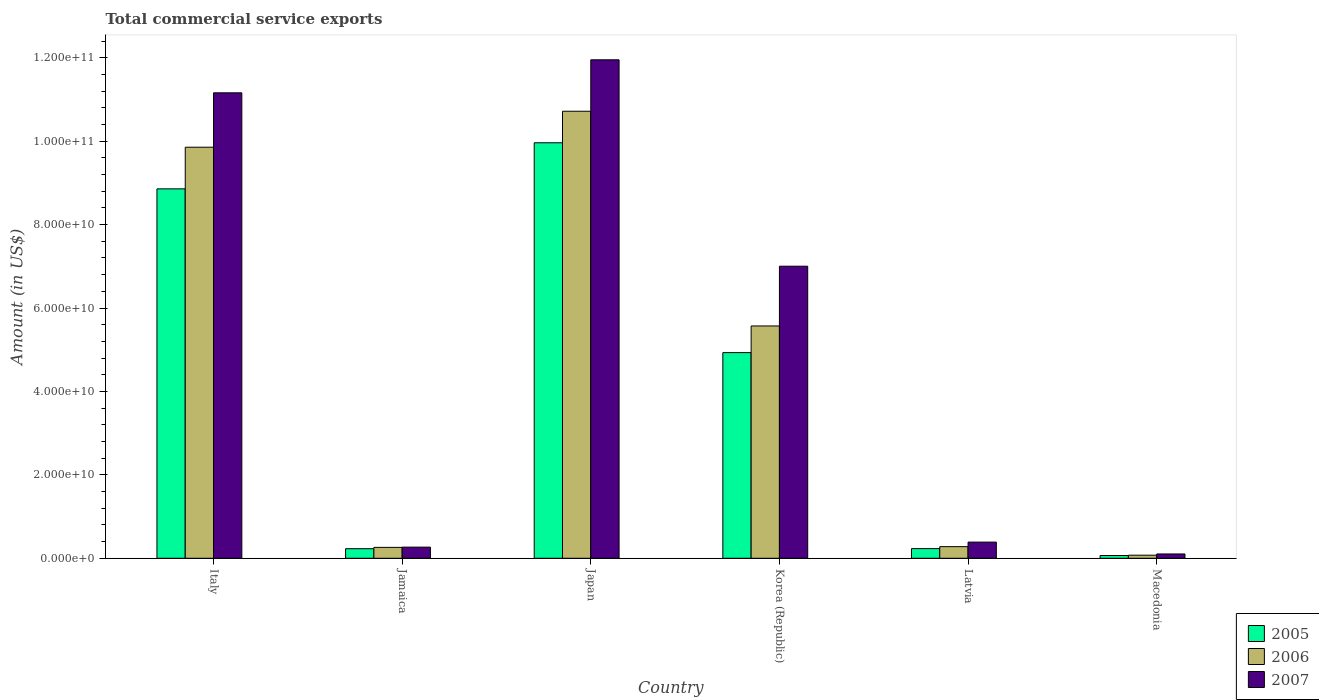How many groups of bars are there?
Your answer should be compact. 6. Are the number of bars on each tick of the X-axis equal?
Keep it short and to the point. Yes. What is the label of the 1st group of bars from the left?
Your answer should be compact. Italy. In how many cases, is the number of bars for a given country not equal to the number of legend labels?
Offer a terse response. 0. What is the total commercial service exports in 2006 in Italy?
Your answer should be very brief. 9.86e+1. Across all countries, what is the maximum total commercial service exports in 2007?
Your answer should be very brief. 1.20e+11. Across all countries, what is the minimum total commercial service exports in 2005?
Provide a short and direct response. 6.60e+08. In which country was the total commercial service exports in 2007 maximum?
Provide a succinct answer. Japan. In which country was the total commercial service exports in 2005 minimum?
Your answer should be compact. Macedonia. What is the total total commercial service exports in 2005 in the graph?
Offer a very short reply. 2.43e+11. What is the difference between the total commercial service exports in 2006 in Italy and that in Latvia?
Provide a succinct answer. 9.58e+1. What is the difference between the total commercial service exports in 2005 in Latvia and the total commercial service exports in 2007 in Japan?
Make the answer very short. -1.17e+11. What is the average total commercial service exports in 2006 per country?
Offer a very short reply. 4.46e+1. What is the difference between the total commercial service exports of/in 2005 and total commercial service exports of/in 2006 in Jamaica?
Keep it short and to the point. -3.18e+08. In how many countries, is the total commercial service exports in 2006 greater than 64000000000 US$?
Offer a terse response. 2. What is the ratio of the total commercial service exports in 2007 in Japan to that in Macedonia?
Make the answer very short. 115.58. Is the total commercial service exports in 2005 in Italy less than that in Japan?
Keep it short and to the point. Yes. Is the difference between the total commercial service exports in 2005 in Jamaica and Japan greater than the difference between the total commercial service exports in 2006 in Jamaica and Japan?
Your answer should be very brief. Yes. What is the difference between the highest and the second highest total commercial service exports in 2006?
Offer a very short reply. -4.29e+1. What is the difference between the highest and the lowest total commercial service exports in 2005?
Your answer should be compact. 9.90e+1. In how many countries, is the total commercial service exports in 2006 greater than the average total commercial service exports in 2006 taken over all countries?
Offer a very short reply. 3. Is it the case that in every country, the sum of the total commercial service exports in 2005 and total commercial service exports in 2006 is greater than the total commercial service exports in 2007?
Your answer should be compact. Yes. How many bars are there?
Your response must be concise. 18. What is the difference between two consecutive major ticks on the Y-axis?
Your response must be concise. 2.00e+1. Are the values on the major ticks of Y-axis written in scientific E-notation?
Your response must be concise. Yes. Does the graph contain grids?
Your answer should be very brief. No. How are the legend labels stacked?
Provide a succinct answer. Vertical. What is the title of the graph?
Keep it short and to the point. Total commercial service exports. What is the label or title of the X-axis?
Offer a terse response. Country. What is the label or title of the Y-axis?
Your answer should be very brief. Amount (in US$). What is the Amount (in US$) in 2005 in Italy?
Your answer should be compact. 8.86e+1. What is the Amount (in US$) in 2006 in Italy?
Your response must be concise. 9.86e+1. What is the Amount (in US$) in 2007 in Italy?
Your response must be concise. 1.12e+11. What is the Amount (in US$) in 2005 in Jamaica?
Offer a terse response. 2.30e+09. What is the Amount (in US$) of 2006 in Jamaica?
Your answer should be very brief. 2.61e+09. What is the Amount (in US$) of 2007 in Jamaica?
Give a very brief answer. 2.67e+09. What is the Amount (in US$) in 2005 in Japan?
Your answer should be compact. 9.96e+1. What is the Amount (in US$) of 2006 in Japan?
Offer a terse response. 1.07e+11. What is the Amount (in US$) in 2007 in Japan?
Your answer should be compact. 1.20e+11. What is the Amount (in US$) in 2005 in Korea (Republic)?
Give a very brief answer. 4.93e+1. What is the Amount (in US$) in 2006 in Korea (Republic)?
Keep it short and to the point. 5.57e+1. What is the Amount (in US$) in 2007 in Korea (Republic)?
Your answer should be compact. 7.00e+1. What is the Amount (in US$) in 2005 in Latvia?
Offer a terse response. 2.32e+09. What is the Amount (in US$) in 2006 in Latvia?
Make the answer very short. 2.79e+09. What is the Amount (in US$) in 2007 in Latvia?
Ensure brevity in your answer.  3.88e+09. What is the Amount (in US$) of 2005 in Macedonia?
Provide a short and direct response. 6.60e+08. What is the Amount (in US$) in 2006 in Macedonia?
Provide a short and direct response. 7.38e+08. What is the Amount (in US$) of 2007 in Macedonia?
Give a very brief answer. 1.03e+09. Across all countries, what is the maximum Amount (in US$) in 2005?
Provide a short and direct response. 9.96e+1. Across all countries, what is the maximum Amount (in US$) of 2006?
Your answer should be very brief. 1.07e+11. Across all countries, what is the maximum Amount (in US$) of 2007?
Provide a short and direct response. 1.20e+11. Across all countries, what is the minimum Amount (in US$) in 2005?
Your response must be concise. 6.60e+08. Across all countries, what is the minimum Amount (in US$) of 2006?
Give a very brief answer. 7.38e+08. Across all countries, what is the minimum Amount (in US$) of 2007?
Provide a succinct answer. 1.03e+09. What is the total Amount (in US$) in 2005 in the graph?
Your response must be concise. 2.43e+11. What is the total Amount (in US$) in 2006 in the graph?
Your answer should be compact. 2.68e+11. What is the total Amount (in US$) in 2007 in the graph?
Your response must be concise. 3.09e+11. What is the difference between the Amount (in US$) in 2005 in Italy and that in Jamaica?
Make the answer very short. 8.63e+1. What is the difference between the Amount (in US$) in 2006 in Italy and that in Jamaica?
Offer a terse response. 9.59e+1. What is the difference between the Amount (in US$) of 2007 in Italy and that in Jamaica?
Keep it short and to the point. 1.09e+11. What is the difference between the Amount (in US$) of 2005 in Italy and that in Japan?
Offer a very short reply. -1.10e+1. What is the difference between the Amount (in US$) of 2006 in Italy and that in Japan?
Provide a short and direct response. -8.63e+09. What is the difference between the Amount (in US$) of 2007 in Italy and that in Japan?
Your answer should be compact. -7.92e+09. What is the difference between the Amount (in US$) of 2005 in Italy and that in Korea (Republic)?
Your response must be concise. 3.93e+1. What is the difference between the Amount (in US$) of 2006 in Italy and that in Korea (Republic)?
Give a very brief answer. 4.29e+1. What is the difference between the Amount (in US$) of 2007 in Italy and that in Korea (Republic)?
Ensure brevity in your answer.  4.16e+1. What is the difference between the Amount (in US$) in 2005 in Italy and that in Latvia?
Ensure brevity in your answer.  8.63e+1. What is the difference between the Amount (in US$) in 2006 in Italy and that in Latvia?
Keep it short and to the point. 9.58e+1. What is the difference between the Amount (in US$) of 2007 in Italy and that in Latvia?
Offer a terse response. 1.08e+11. What is the difference between the Amount (in US$) in 2005 in Italy and that in Macedonia?
Your answer should be compact. 8.79e+1. What is the difference between the Amount (in US$) of 2006 in Italy and that in Macedonia?
Ensure brevity in your answer.  9.78e+1. What is the difference between the Amount (in US$) of 2007 in Italy and that in Macedonia?
Provide a succinct answer. 1.11e+11. What is the difference between the Amount (in US$) in 2005 in Jamaica and that in Japan?
Keep it short and to the point. -9.73e+1. What is the difference between the Amount (in US$) in 2006 in Jamaica and that in Japan?
Keep it short and to the point. -1.05e+11. What is the difference between the Amount (in US$) in 2007 in Jamaica and that in Japan?
Your response must be concise. -1.17e+11. What is the difference between the Amount (in US$) in 2005 in Jamaica and that in Korea (Republic)?
Your response must be concise. -4.70e+1. What is the difference between the Amount (in US$) of 2006 in Jamaica and that in Korea (Republic)?
Provide a short and direct response. -5.31e+1. What is the difference between the Amount (in US$) of 2007 in Jamaica and that in Korea (Republic)?
Offer a terse response. -6.74e+1. What is the difference between the Amount (in US$) of 2005 in Jamaica and that in Latvia?
Make the answer very short. -2.24e+07. What is the difference between the Amount (in US$) in 2006 in Jamaica and that in Latvia?
Your answer should be compact. -1.75e+08. What is the difference between the Amount (in US$) of 2007 in Jamaica and that in Latvia?
Keep it short and to the point. -1.21e+09. What is the difference between the Amount (in US$) of 2005 in Jamaica and that in Macedonia?
Your answer should be compact. 1.64e+09. What is the difference between the Amount (in US$) in 2006 in Jamaica and that in Macedonia?
Offer a terse response. 1.88e+09. What is the difference between the Amount (in US$) of 2007 in Jamaica and that in Macedonia?
Your response must be concise. 1.64e+09. What is the difference between the Amount (in US$) in 2005 in Japan and that in Korea (Republic)?
Make the answer very short. 5.03e+1. What is the difference between the Amount (in US$) in 2006 in Japan and that in Korea (Republic)?
Keep it short and to the point. 5.15e+1. What is the difference between the Amount (in US$) in 2007 in Japan and that in Korea (Republic)?
Your response must be concise. 4.95e+1. What is the difference between the Amount (in US$) in 2005 in Japan and that in Latvia?
Your response must be concise. 9.73e+1. What is the difference between the Amount (in US$) of 2006 in Japan and that in Latvia?
Keep it short and to the point. 1.04e+11. What is the difference between the Amount (in US$) in 2007 in Japan and that in Latvia?
Give a very brief answer. 1.16e+11. What is the difference between the Amount (in US$) in 2005 in Japan and that in Macedonia?
Give a very brief answer. 9.90e+1. What is the difference between the Amount (in US$) of 2006 in Japan and that in Macedonia?
Your answer should be compact. 1.06e+11. What is the difference between the Amount (in US$) in 2007 in Japan and that in Macedonia?
Your answer should be very brief. 1.18e+11. What is the difference between the Amount (in US$) of 2005 in Korea (Republic) and that in Latvia?
Make the answer very short. 4.70e+1. What is the difference between the Amount (in US$) of 2006 in Korea (Republic) and that in Latvia?
Keep it short and to the point. 5.29e+1. What is the difference between the Amount (in US$) in 2007 in Korea (Republic) and that in Latvia?
Provide a short and direct response. 6.62e+1. What is the difference between the Amount (in US$) in 2005 in Korea (Republic) and that in Macedonia?
Offer a terse response. 4.87e+1. What is the difference between the Amount (in US$) in 2006 in Korea (Republic) and that in Macedonia?
Keep it short and to the point. 5.50e+1. What is the difference between the Amount (in US$) of 2007 in Korea (Republic) and that in Macedonia?
Keep it short and to the point. 6.90e+1. What is the difference between the Amount (in US$) in 2005 in Latvia and that in Macedonia?
Your response must be concise. 1.66e+09. What is the difference between the Amount (in US$) of 2006 in Latvia and that in Macedonia?
Offer a terse response. 2.05e+09. What is the difference between the Amount (in US$) in 2007 in Latvia and that in Macedonia?
Give a very brief answer. 2.84e+09. What is the difference between the Amount (in US$) in 2005 in Italy and the Amount (in US$) in 2006 in Jamaica?
Keep it short and to the point. 8.60e+1. What is the difference between the Amount (in US$) in 2005 in Italy and the Amount (in US$) in 2007 in Jamaica?
Your answer should be very brief. 8.59e+1. What is the difference between the Amount (in US$) in 2006 in Italy and the Amount (in US$) in 2007 in Jamaica?
Your answer should be compact. 9.59e+1. What is the difference between the Amount (in US$) in 2005 in Italy and the Amount (in US$) in 2006 in Japan?
Offer a terse response. -1.86e+1. What is the difference between the Amount (in US$) in 2005 in Italy and the Amount (in US$) in 2007 in Japan?
Keep it short and to the point. -3.09e+1. What is the difference between the Amount (in US$) in 2006 in Italy and the Amount (in US$) in 2007 in Japan?
Your answer should be very brief. -2.10e+1. What is the difference between the Amount (in US$) in 2005 in Italy and the Amount (in US$) in 2006 in Korea (Republic)?
Offer a very short reply. 3.29e+1. What is the difference between the Amount (in US$) in 2005 in Italy and the Amount (in US$) in 2007 in Korea (Republic)?
Your response must be concise. 1.85e+1. What is the difference between the Amount (in US$) of 2006 in Italy and the Amount (in US$) of 2007 in Korea (Republic)?
Provide a succinct answer. 2.85e+1. What is the difference between the Amount (in US$) in 2005 in Italy and the Amount (in US$) in 2006 in Latvia?
Offer a very short reply. 8.58e+1. What is the difference between the Amount (in US$) in 2005 in Italy and the Amount (in US$) in 2007 in Latvia?
Offer a terse response. 8.47e+1. What is the difference between the Amount (in US$) in 2006 in Italy and the Amount (in US$) in 2007 in Latvia?
Offer a terse response. 9.47e+1. What is the difference between the Amount (in US$) of 2005 in Italy and the Amount (in US$) of 2006 in Macedonia?
Provide a succinct answer. 8.78e+1. What is the difference between the Amount (in US$) in 2005 in Italy and the Amount (in US$) in 2007 in Macedonia?
Make the answer very short. 8.75e+1. What is the difference between the Amount (in US$) in 2006 in Italy and the Amount (in US$) in 2007 in Macedonia?
Ensure brevity in your answer.  9.75e+1. What is the difference between the Amount (in US$) of 2005 in Jamaica and the Amount (in US$) of 2006 in Japan?
Offer a very short reply. -1.05e+11. What is the difference between the Amount (in US$) in 2005 in Jamaica and the Amount (in US$) in 2007 in Japan?
Give a very brief answer. -1.17e+11. What is the difference between the Amount (in US$) of 2006 in Jamaica and the Amount (in US$) of 2007 in Japan?
Make the answer very short. -1.17e+11. What is the difference between the Amount (in US$) in 2005 in Jamaica and the Amount (in US$) in 2006 in Korea (Republic)?
Offer a terse response. -5.34e+1. What is the difference between the Amount (in US$) in 2005 in Jamaica and the Amount (in US$) in 2007 in Korea (Republic)?
Ensure brevity in your answer.  -6.77e+1. What is the difference between the Amount (in US$) of 2006 in Jamaica and the Amount (in US$) of 2007 in Korea (Republic)?
Your answer should be very brief. -6.74e+1. What is the difference between the Amount (in US$) of 2005 in Jamaica and the Amount (in US$) of 2006 in Latvia?
Ensure brevity in your answer.  -4.93e+08. What is the difference between the Amount (in US$) of 2005 in Jamaica and the Amount (in US$) of 2007 in Latvia?
Offer a very short reply. -1.58e+09. What is the difference between the Amount (in US$) in 2006 in Jamaica and the Amount (in US$) in 2007 in Latvia?
Your answer should be compact. -1.26e+09. What is the difference between the Amount (in US$) of 2005 in Jamaica and the Amount (in US$) of 2006 in Macedonia?
Your response must be concise. 1.56e+09. What is the difference between the Amount (in US$) in 2005 in Jamaica and the Amount (in US$) in 2007 in Macedonia?
Provide a succinct answer. 1.26e+09. What is the difference between the Amount (in US$) in 2006 in Jamaica and the Amount (in US$) in 2007 in Macedonia?
Provide a succinct answer. 1.58e+09. What is the difference between the Amount (in US$) of 2005 in Japan and the Amount (in US$) of 2006 in Korea (Republic)?
Your answer should be very brief. 4.39e+1. What is the difference between the Amount (in US$) of 2005 in Japan and the Amount (in US$) of 2007 in Korea (Republic)?
Make the answer very short. 2.96e+1. What is the difference between the Amount (in US$) of 2006 in Japan and the Amount (in US$) of 2007 in Korea (Republic)?
Your response must be concise. 3.72e+1. What is the difference between the Amount (in US$) of 2005 in Japan and the Amount (in US$) of 2006 in Latvia?
Provide a short and direct response. 9.68e+1. What is the difference between the Amount (in US$) of 2005 in Japan and the Amount (in US$) of 2007 in Latvia?
Ensure brevity in your answer.  9.57e+1. What is the difference between the Amount (in US$) of 2006 in Japan and the Amount (in US$) of 2007 in Latvia?
Ensure brevity in your answer.  1.03e+11. What is the difference between the Amount (in US$) of 2005 in Japan and the Amount (in US$) of 2006 in Macedonia?
Your response must be concise. 9.89e+1. What is the difference between the Amount (in US$) in 2005 in Japan and the Amount (in US$) in 2007 in Macedonia?
Keep it short and to the point. 9.86e+1. What is the difference between the Amount (in US$) of 2006 in Japan and the Amount (in US$) of 2007 in Macedonia?
Your answer should be very brief. 1.06e+11. What is the difference between the Amount (in US$) of 2005 in Korea (Republic) and the Amount (in US$) of 2006 in Latvia?
Your response must be concise. 4.65e+1. What is the difference between the Amount (in US$) in 2005 in Korea (Republic) and the Amount (in US$) in 2007 in Latvia?
Your response must be concise. 4.54e+1. What is the difference between the Amount (in US$) in 2006 in Korea (Republic) and the Amount (in US$) in 2007 in Latvia?
Offer a terse response. 5.18e+1. What is the difference between the Amount (in US$) in 2005 in Korea (Republic) and the Amount (in US$) in 2006 in Macedonia?
Offer a terse response. 4.86e+1. What is the difference between the Amount (in US$) in 2005 in Korea (Republic) and the Amount (in US$) in 2007 in Macedonia?
Give a very brief answer. 4.83e+1. What is the difference between the Amount (in US$) in 2006 in Korea (Republic) and the Amount (in US$) in 2007 in Macedonia?
Your answer should be very brief. 5.47e+1. What is the difference between the Amount (in US$) in 2005 in Latvia and the Amount (in US$) in 2006 in Macedonia?
Your response must be concise. 1.58e+09. What is the difference between the Amount (in US$) in 2005 in Latvia and the Amount (in US$) in 2007 in Macedonia?
Make the answer very short. 1.28e+09. What is the difference between the Amount (in US$) of 2006 in Latvia and the Amount (in US$) of 2007 in Macedonia?
Offer a terse response. 1.75e+09. What is the average Amount (in US$) of 2005 per country?
Your response must be concise. 4.05e+1. What is the average Amount (in US$) of 2006 per country?
Ensure brevity in your answer.  4.46e+1. What is the average Amount (in US$) of 2007 per country?
Provide a short and direct response. 5.15e+1. What is the difference between the Amount (in US$) in 2005 and Amount (in US$) in 2006 in Italy?
Make the answer very short. -9.98e+09. What is the difference between the Amount (in US$) in 2005 and Amount (in US$) in 2007 in Italy?
Ensure brevity in your answer.  -2.30e+1. What is the difference between the Amount (in US$) of 2006 and Amount (in US$) of 2007 in Italy?
Offer a very short reply. -1.30e+1. What is the difference between the Amount (in US$) in 2005 and Amount (in US$) in 2006 in Jamaica?
Offer a terse response. -3.18e+08. What is the difference between the Amount (in US$) of 2005 and Amount (in US$) of 2007 in Jamaica?
Ensure brevity in your answer.  -3.74e+08. What is the difference between the Amount (in US$) in 2006 and Amount (in US$) in 2007 in Jamaica?
Keep it short and to the point. -5.61e+07. What is the difference between the Amount (in US$) of 2005 and Amount (in US$) of 2006 in Japan?
Provide a succinct answer. -7.56e+09. What is the difference between the Amount (in US$) in 2005 and Amount (in US$) in 2007 in Japan?
Keep it short and to the point. -1.99e+1. What is the difference between the Amount (in US$) of 2006 and Amount (in US$) of 2007 in Japan?
Provide a short and direct response. -1.23e+1. What is the difference between the Amount (in US$) in 2005 and Amount (in US$) in 2006 in Korea (Republic)?
Your answer should be very brief. -6.39e+09. What is the difference between the Amount (in US$) in 2005 and Amount (in US$) in 2007 in Korea (Republic)?
Your answer should be very brief. -2.07e+1. What is the difference between the Amount (in US$) of 2006 and Amount (in US$) of 2007 in Korea (Republic)?
Your answer should be very brief. -1.43e+1. What is the difference between the Amount (in US$) in 2005 and Amount (in US$) in 2006 in Latvia?
Offer a very short reply. -4.70e+08. What is the difference between the Amount (in US$) in 2005 and Amount (in US$) in 2007 in Latvia?
Ensure brevity in your answer.  -1.56e+09. What is the difference between the Amount (in US$) in 2006 and Amount (in US$) in 2007 in Latvia?
Provide a succinct answer. -1.09e+09. What is the difference between the Amount (in US$) in 2005 and Amount (in US$) in 2006 in Macedonia?
Give a very brief answer. -7.75e+07. What is the difference between the Amount (in US$) of 2005 and Amount (in US$) of 2007 in Macedonia?
Provide a succinct answer. -3.74e+08. What is the difference between the Amount (in US$) of 2006 and Amount (in US$) of 2007 in Macedonia?
Give a very brief answer. -2.96e+08. What is the ratio of the Amount (in US$) of 2005 in Italy to that in Jamaica?
Give a very brief answer. 38.59. What is the ratio of the Amount (in US$) in 2006 in Italy to that in Jamaica?
Ensure brevity in your answer.  37.71. What is the ratio of the Amount (in US$) of 2007 in Italy to that in Jamaica?
Offer a terse response. 41.81. What is the ratio of the Amount (in US$) of 2005 in Italy to that in Japan?
Keep it short and to the point. 0.89. What is the ratio of the Amount (in US$) in 2006 in Italy to that in Japan?
Give a very brief answer. 0.92. What is the ratio of the Amount (in US$) in 2007 in Italy to that in Japan?
Your answer should be compact. 0.93. What is the ratio of the Amount (in US$) of 2005 in Italy to that in Korea (Republic)?
Provide a succinct answer. 1.8. What is the ratio of the Amount (in US$) of 2006 in Italy to that in Korea (Republic)?
Your answer should be very brief. 1.77. What is the ratio of the Amount (in US$) of 2007 in Italy to that in Korea (Republic)?
Provide a succinct answer. 1.59. What is the ratio of the Amount (in US$) in 2005 in Italy to that in Latvia?
Your response must be concise. 38.21. What is the ratio of the Amount (in US$) in 2006 in Italy to that in Latvia?
Provide a succinct answer. 35.35. What is the ratio of the Amount (in US$) in 2007 in Italy to that in Latvia?
Ensure brevity in your answer.  28.78. What is the ratio of the Amount (in US$) in 2005 in Italy to that in Macedonia?
Provide a short and direct response. 134.13. What is the ratio of the Amount (in US$) of 2006 in Italy to that in Macedonia?
Ensure brevity in your answer.  133.57. What is the ratio of the Amount (in US$) of 2007 in Italy to that in Macedonia?
Provide a succinct answer. 107.92. What is the ratio of the Amount (in US$) of 2005 in Jamaica to that in Japan?
Offer a terse response. 0.02. What is the ratio of the Amount (in US$) in 2006 in Jamaica to that in Japan?
Your response must be concise. 0.02. What is the ratio of the Amount (in US$) of 2007 in Jamaica to that in Japan?
Provide a short and direct response. 0.02. What is the ratio of the Amount (in US$) of 2005 in Jamaica to that in Korea (Republic)?
Offer a very short reply. 0.05. What is the ratio of the Amount (in US$) in 2006 in Jamaica to that in Korea (Republic)?
Offer a very short reply. 0.05. What is the ratio of the Amount (in US$) in 2007 in Jamaica to that in Korea (Republic)?
Your answer should be compact. 0.04. What is the ratio of the Amount (in US$) in 2005 in Jamaica to that in Latvia?
Give a very brief answer. 0.99. What is the ratio of the Amount (in US$) in 2006 in Jamaica to that in Latvia?
Your response must be concise. 0.94. What is the ratio of the Amount (in US$) of 2007 in Jamaica to that in Latvia?
Your answer should be compact. 0.69. What is the ratio of the Amount (in US$) of 2005 in Jamaica to that in Macedonia?
Your answer should be very brief. 3.48. What is the ratio of the Amount (in US$) in 2006 in Jamaica to that in Macedonia?
Keep it short and to the point. 3.54. What is the ratio of the Amount (in US$) of 2007 in Jamaica to that in Macedonia?
Give a very brief answer. 2.58. What is the ratio of the Amount (in US$) of 2005 in Japan to that in Korea (Republic)?
Ensure brevity in your answer.  2.02. What is the ratio of the Amount (in US$) in 2006 in Japan to that in Korea (Republic)?
Your answer should be compact. 1.92. What is the ratio of the Amount (in US$) in 2007 in Japan to that in Korea (Republic)?
Your response must be concise. 1.71. What is the ratio of the Amount (in US$) of 2005 in Japan to that in Latvia?
Your answer should be very brief. 42.98. What is the ratio of the Amount (in US$) in 2006 in Japan to that in Latvia?
Provide a short and direct response. 38.44. What is the ratio of the Amount (in US$) of 2007 in Japan to that in Latvia?
Keep it short and to the point. 30.82. What is the ratio of the Amount (in US$) in 2005 in Japan to that in Macedonia?
Keep it short and to the point. 150.86. What is the ratio of the Amount (in US$) in 2006 in Japan to that in Macedonia?
Your answer should be compact. 145.26. What is the ratio of the Amount (in US$) of 2007 in Japan to that in Macedonia?
Your answer should be very brief. 115.58. What is the ratio of the Amount (in US$) of 2005 in Korea (Republic) to that in Latvia?
Your answer should be very brief. 21.27. What is the ratio of the Amount (in US$) in 2006 in Korea (Republic) to that in Latvia?
Ensure brevity in your answer.  19.98. What is the ratio of the Amount (in US$) of 2007 in Korea (Republic) to that in Latvia?
Your response must be concise. 18.06. What is the ratio of the Amount (in US$) in 2005 in Korea (Republic) to that in Macedonia?
Give a very brief answer. 74.67. What is the ratio of the Amount (in US$) in 2006 in Korea (Republic) to that in Macedonia?
Provide a short and direct response. 75.49. What is the ratio of the Amount (in US$) of 2007 in Korea (Republic) to that in Macedonia?
Your response must be concise. 67.72. What is the ratio of the Amount (in US$) of 2005 in Latvia to that in Macedonia?
Give a very brief answer. 3.51. What is the ratio of the Amount (in US$) of 2006 in Latvia to that in Macedonia?
Your answer should be compact. 3.78. What is the ratio of the Amount (in US$) in 2007 in Latvia to that in Macedonia?
Your answer should be compact. 3.75. What is the difference between the highest and the second highest Amount (in US$) of 2005?
Offer a very short reply. 1.10e+1. What is the difference between the highest and the second highest Amount (in US$) in 2006?
Your response must be concise. 8.63e+09. What is the difference between the highest and the second highest Amount (in US$) in 2007?
Your answer should be very brief. 7.92e+09. What is the difference between the highest and the lowest Amount (in US$) of 2005?
Make the answer very short. 9.90e+1. What is the difference between the highest and the lowest Amount (in US$) in 2006?
Provide a short and direct response. 1.06e+11. What is the difference between the highest and the lowest Amount (in US$) in 2007?
Ensure brevity in your answer.  1.18e+11. 